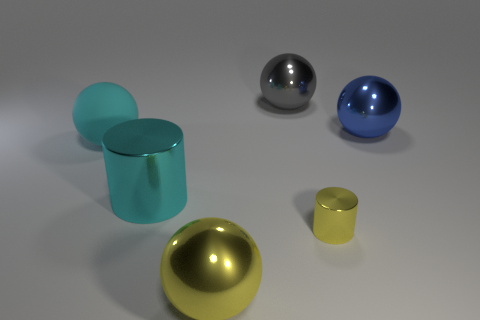Subtract all yellow balls. How many balls are left? 3 Add 2 yellow rubber cubes. How many objects exist? 8 Subtract all cylinders. How many objects are left? 4 Subtract 4 balls. How many balls are left? 0 Add 1 tiny yellow shiny cylinders. How many tiny yellow shiny cylinders exist? 2 Subtract all gray spheres. How many spheres are left? 3 Subtract 0 purple spheres. How many objects are left? 6 Subtract all yellow cylinders. Subtract all cyan spheres. How many cylinders are left? 1 Subtract all yellow cylinders. How many blue spheres are left? 1 Subtract all cyan shiny cylinders. Subtract all cyan cylinders. How many objects are left? 4 